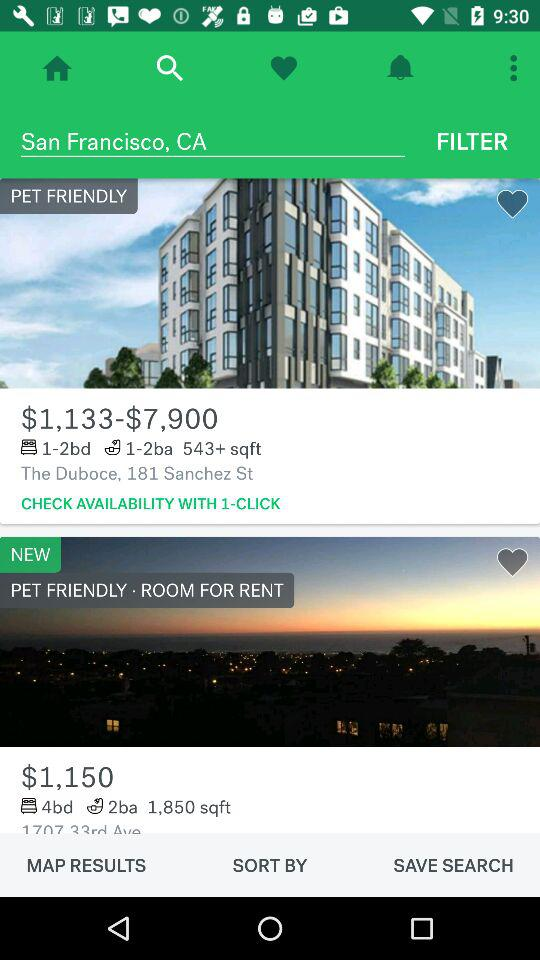What is the price of the room with 4 beds and 2 bathrooms? The price of the room with 4 beds and 2 bathrooms is $1,150. 